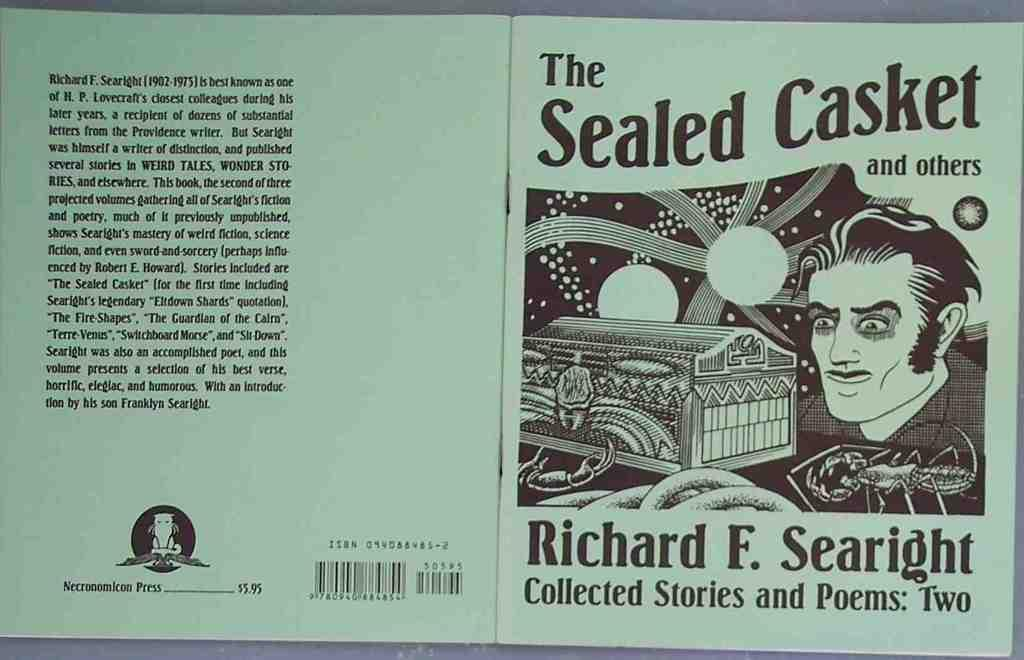<image>
Render a clear and concise summary of the photo. The cover of a collection of stories and poems called The Sealed Casket and others, written by Richard F Searight. 